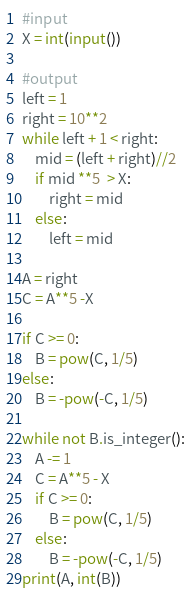<code> <loc_0><loc_0><loc_500><loc_500><_Python_>#input
X = int(input())

#output
left = 1
right = 10**2
while left + 1 < right:
    mid = (left + right)//2
    if mid **5  > X:
        right = mid
    else:
        left = mid

A = right
C = A**5 -X

if C >= 0:
    B = pow(C, 1/5)
else:
    B = -pow(-C, 1/5)

while not B.is_integer():
    A -= 1
    C = A**5 - X
    if C >= 0:
        B = pow(C, 1/5)
    else:
        B = -pow(-C, 1/5)
print(A, int(B))</code> 